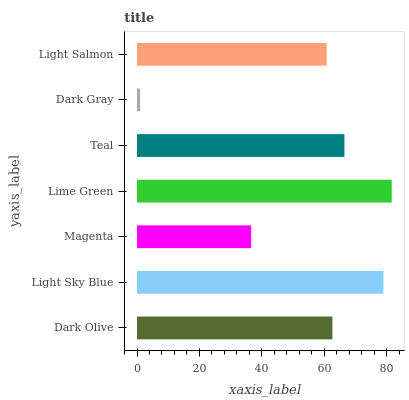Is Dark Gray the minimum?
Answer yes or no. Yes. Is Lime Green the maximum?
Answer yes or no. Yes. Is Light Sky Blue the minimum?
Answer yes or no. No. Is Light Sky Blue the maximum?
Answer yes or no. No. Is Light Sky Blue greater than Dark Olive?
Answer yes or no. Yes. Is Dark Olive less than Light Sky Blue?
Answer yes or no. Yes. Is Dark Olive greater than Light Sky Blue?
Answer yes or no. No. Is Light Sky Blue less than Dark Olive?
Answer yes or no. No. Is Dark Olive the high median?
Answer yes or no. Yes. Is Dark Olive the low median?
Answer yes or no. Yes. Is Lime Green the high median?
Answer yes or no. No. Is Lime Green the low median?
Answer yes or no. No. 